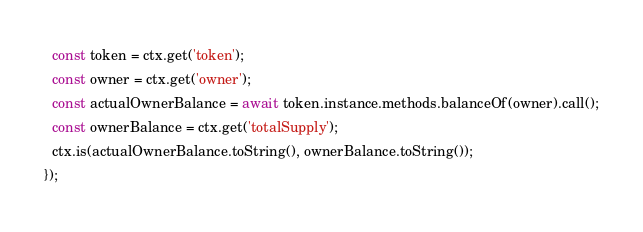Convert code to text. <code><loc_0><loc_0><loc_500><loc_500><_TypeScript_>  const token = ctx.get('token');
  const owner = ctx.get('owner');
  const actualOwnerBalance = await token.instance.methods.balanceOf(owner).call();
  const ownerBalance = ctx.get('totalSupply');
  ctx.is(actualOwnerBalance.toString(), ownerBalance.toString());
});
</code> 